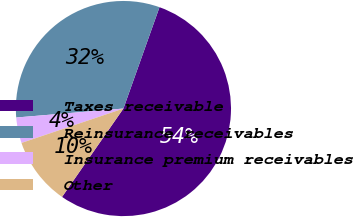<chart> <loc_0><loc_0><loc_500><loc_500><pie_chart><fcel>Taxes receivable<fcel>Reinsurance receivables<fcel>Insurance premium receivables<fcel>Other<nl><fcel>54.22%<fcel>31.77%<fcel>3.85%<fcel>10.16%<nl></chart> 